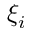Convert formula to latex. <formula><loc_0><loc_0><loc_500><loc_500>\xi _ { i }</formula> 